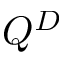Convert formula to latex. <formula><loc_0><loc_0><loc_500><loc_500>Q ^ { D }</formula> 